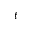Convert formula to latex. <formula><loc_0><loc_0><loc_500><loc_500>t</formula> 